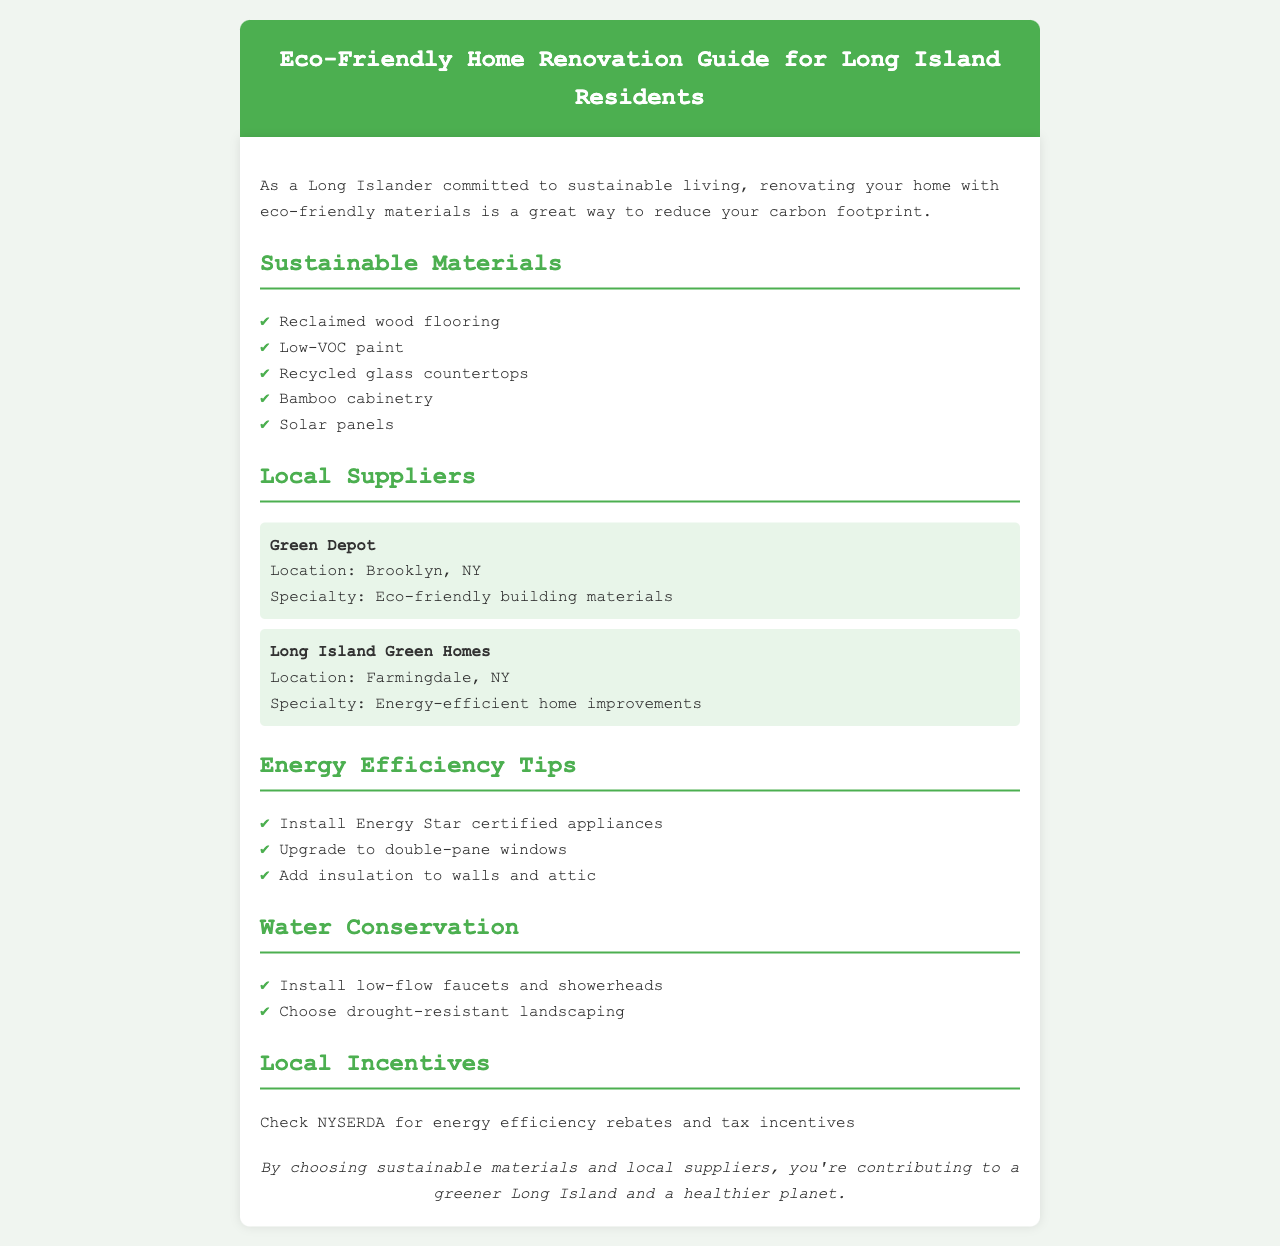what is the title of the guide? The title of the guide is indicated in the header as the main subject of the document.
Answer: Eco-Friendly Home Renovation Guide for Long Island Residents what type of flooring is recommended? The document lists specific sustainable materials to use, one of which is mentioned in the materials section.
Answer: Reclaimed wood flooring where is Long Island Green Homes located? The location of the local supplier is stated in the supplier section of the document.
Answer: Farmingdale, NY name one energy efficiency tip. The document provides a list of tips, and one example can be found in the energy efficiency tips section.
Answer: Install Energy Star certified appliances what does NYSERDA provide? The document mentions NYSERDA in the context of available local incentives.
Answer: Energy efficiency rebates and tax incentives what type of paint is recommended? The guide recommends specific materials, including a particular type of paint.
Answer: Low-VOC paint which supplier specializes in eco-friendly building materials? The document describes each local supplier and their specializations, indicating this specific supplier.
Answer: Green Depot how many types of sustainable materials are listed? The document provides a list of items under the sustainable materials section, allowing for a count.
Answer: Five 